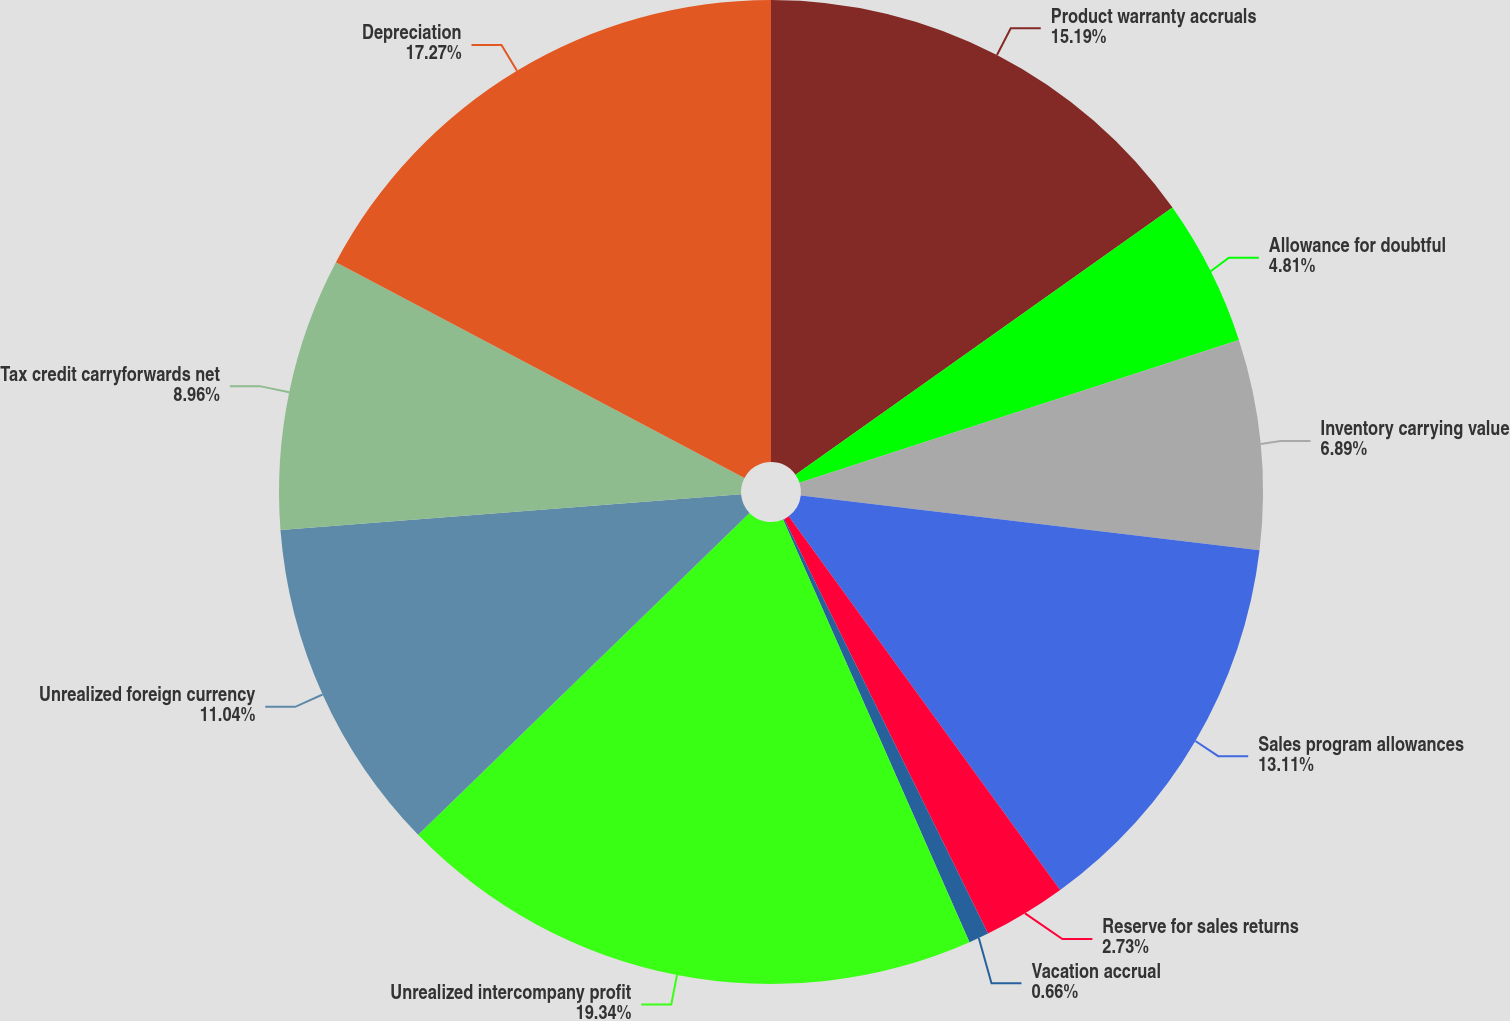Convert chart. <chart><loc_0><loc_0><loc_500><loc_500><pie_chart><fcel>Product warranty accruals<fcel>Allowance for doubtful<fcel>Inventory carrying value<fcel>Sales program allowances<fcel>Reserve for sales returns<fcel>Vacation accrual<fcel>Unrealized intercompany profit<fcel>Unrealized foreign currency<fcel>Tax credit carryforwards net<fcel>Depreciation<nl><fcel>15.19%<fcel>4.81%<fcel>6.89%<fcel>13.11%<fcel>2.73%<fcel>0.66%<fcel>19.34%<fcel>11.04%<fcel>8.96%<fcel>17.27%<nl></chart> 